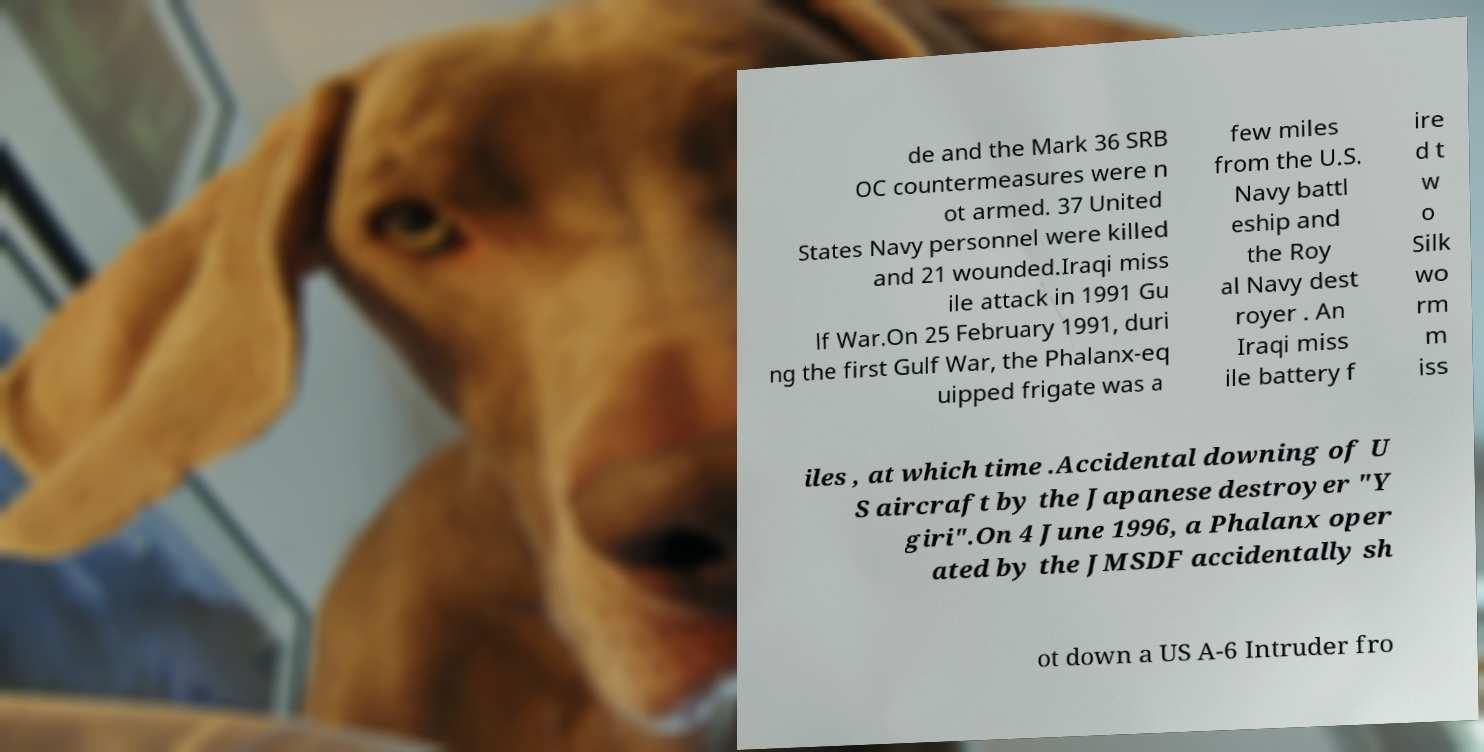Could you assist in decoding the text presented in this image and type it out clearly? de and the Mark 36 SRB OC countermeasures were n ot armed. 37 United States Navy personnel were killed and 21 wounded.Iraqi miss ile attack in 1991 Gu lf War.On 25 February 1991, duri ng the first Gulf War, the Phalanx-eq uipped frigate was a few miles from the U.S. Navy battl eship and the Roy al Navy dest royer . An Iraqi miss ile battery f ire d t w o Silk wo rm m iss iles , at which time .Accidental downing of U S aircraft by the Japanese destroyer "Y giri".On 4 June 1996, a Phalanx oper ated by the JMSDF accidentally sh ot down a US A-6 Intruder fro 